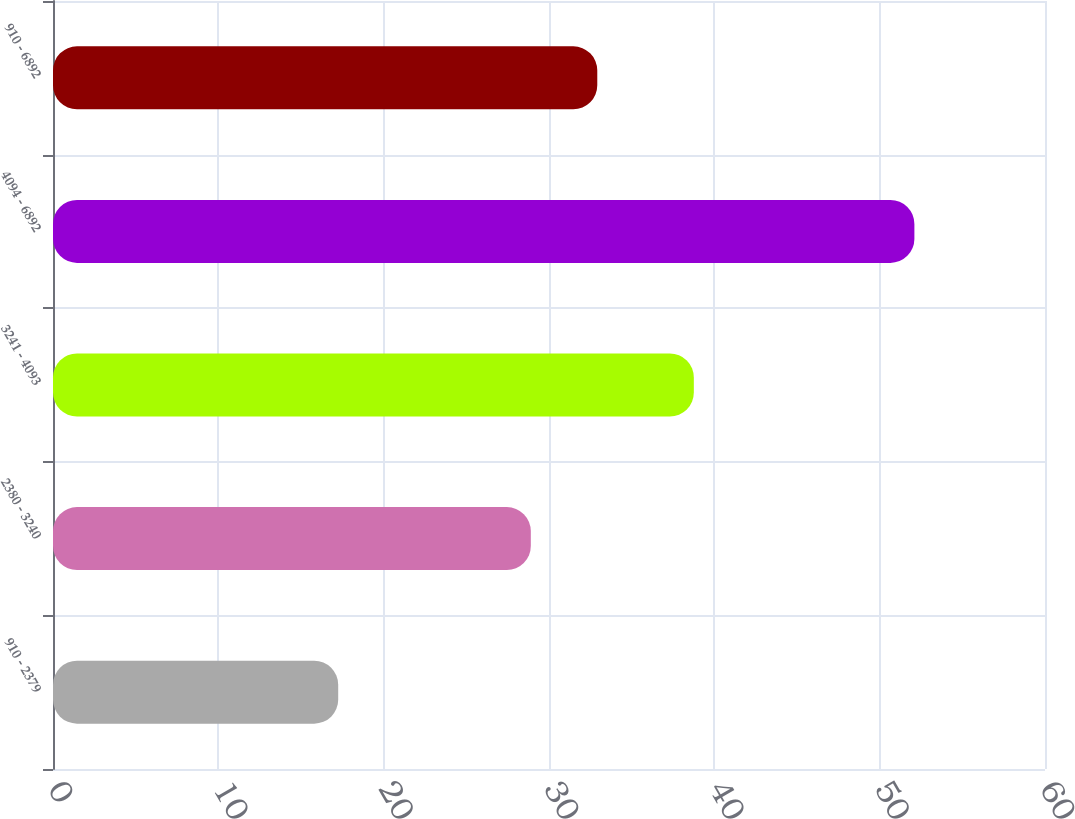Convert chart to OTSL. <chart><loc_0><loc_0><loc_500><loc_500><bar_chart><fcel>910 - 2379<fcel>2380 - 3240<fcel>3241 - 4093<fcel>4094 - 6892<fcel>910 - 6892<nl><fcel>17.25<fcel>28.9<fcel>38.76<fcel>52.1<fcel>32.92<nl></chart> 